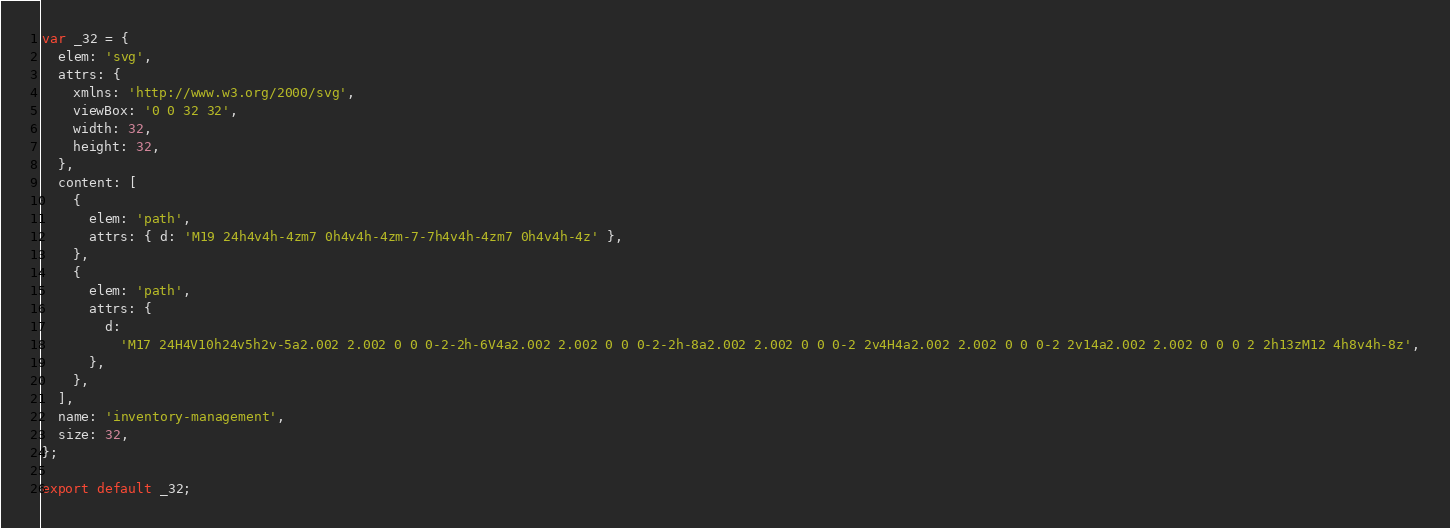Convert code to text. <code><loc_0><loc_0><loc_500><loc_500><_JavaScript_>var _32 = {
  elem: 'svg',
  attrs: {
    xmlns: 'http://www.w3.org/2000/svg',
    viewBox: '0 0 32 32',
    width: 32,
    height: 32,
  },
  content: [
    {
      elem: 'path',
      attrs: { d: 'M19 24h4v4h-4zm7 0h4v4h-4zm-7-7h4v4h-4zm7 0h4v4h-4z' },
    },
    {
      elem: 'path',
      attrs: {
        d:
          'M17 24H4V10h24v5h2v-5a2.002 2.002 0 0 0-2-2h-6V4a2.002 2.002 0 0 0-2-2h-8a2.002 2.002 0 0 0-2 2v4H4a2.002 2.002 0 0 0-2 2v14a2.002 2.002 0 0 0 2 2h13zM12 4h8v4h-8z',
      },
    },
  ],
  name: 'inventory-management',
  size: 32,
};

export default _32;
</code> 